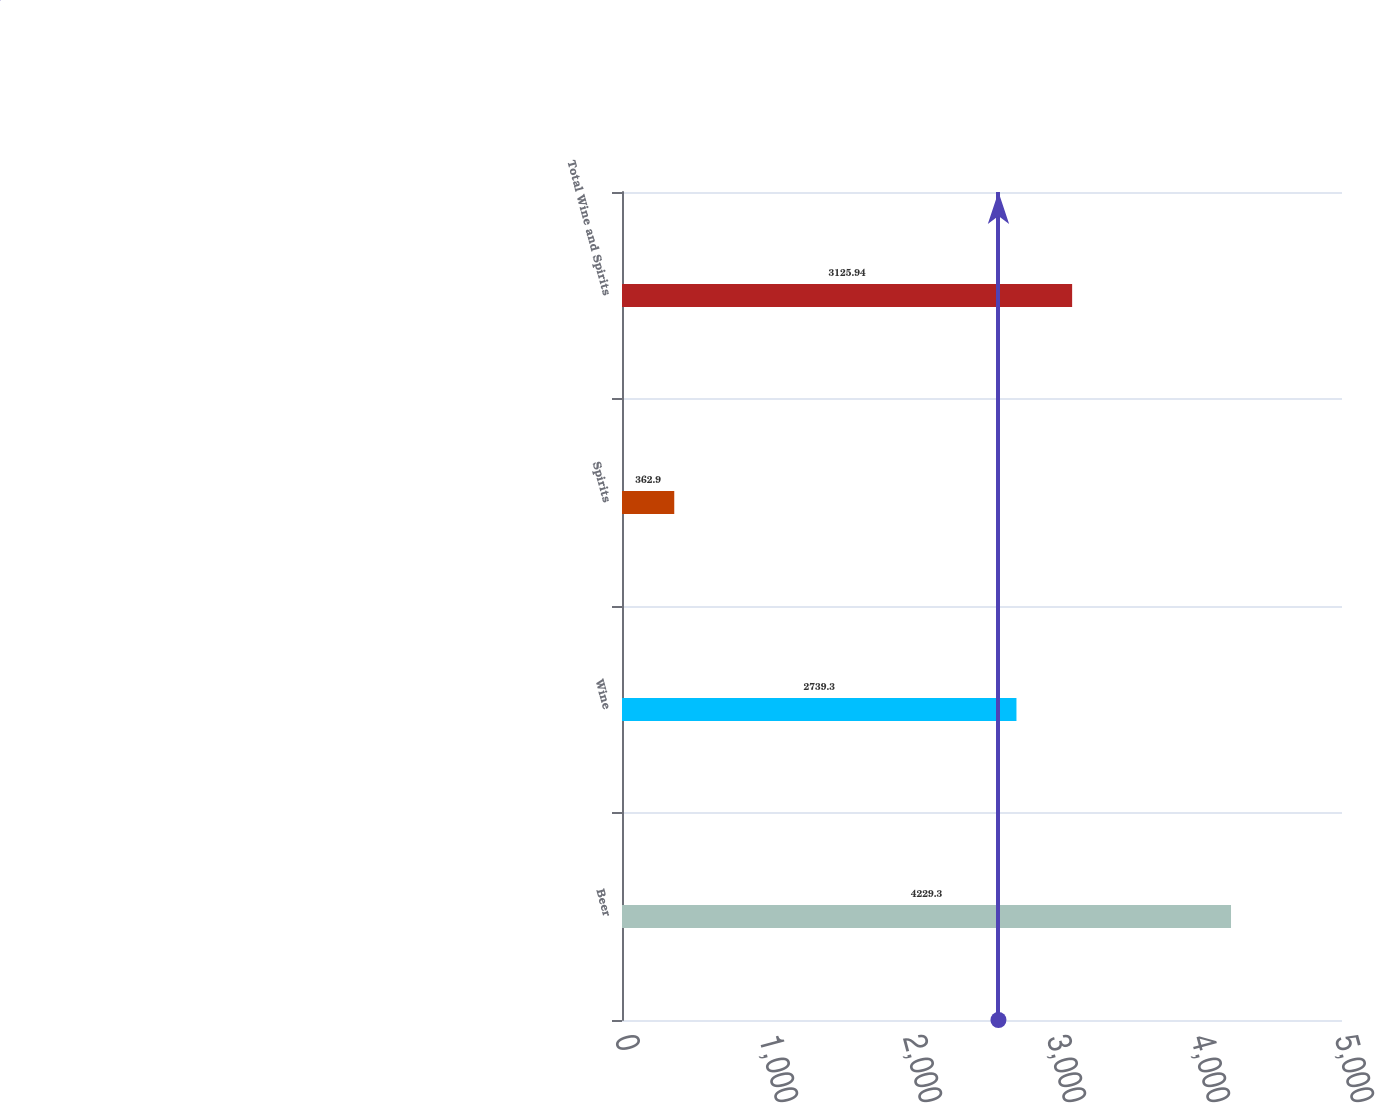<chart> <loc_0><loc_0><loc_500><loc_500><bar_chart><fcel>Beer<fcel>Wine<fcel>Spirits<fcel>Total Wine and Spirits<nl><fcel>4229.3<fcel>2739.3<fcel>362.9<fcel>3125.94<nl></chart> 